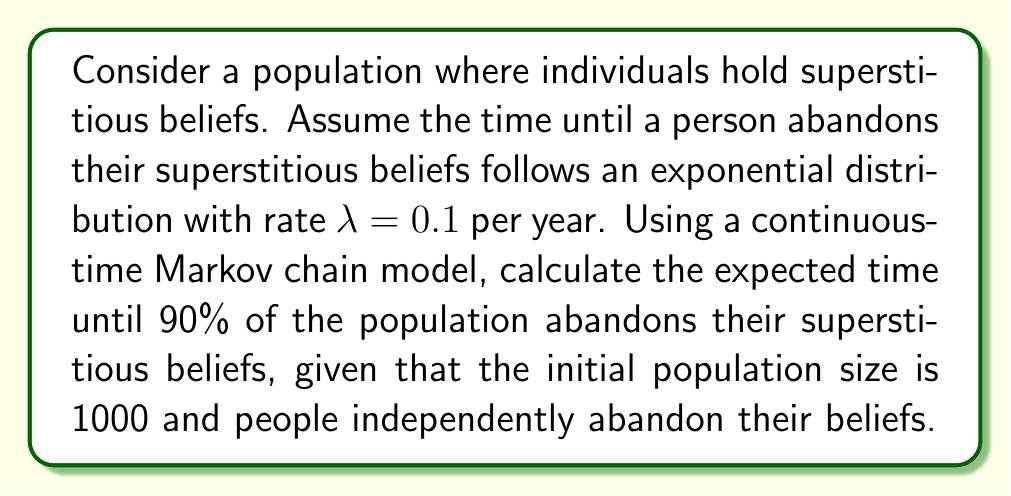Teach me how to tackle this problem. Let's approach this step-by-step:

1) First, we need to understand what we're calculating. We want the expected time until 900 people (90% of 1000) have abandoned their superstitious beliefs.

2) In a continuous-time Markov chain where each individual independently transitions at rate $\lambda$, the time until the $k$-th transition follows an Erlang distribution with parameters $k$ and $n\lambda$, where $n$ is the current number of individuals who haven't yet transitioned.

3) The probability density function of the Erlang distribution is:

   $$f(t;k,\theta) = \frac{t^{k-1}e^{-t/\theta}}{(k-1)!\theta^k}$$

   where $k$ is the shape parameter and $\theta$ is the scale parameter.

4) In our case, $k = 900$ (we want 900 people to abandon their beliefs), and $\theta = \frac{1}{n\lambda}$ where $n$ starts at 1000 and decreases with each transition.

5) The expected value of an Erlang distribution is $k\theta$. However, because $n$ is changing, we need to sum up the expected times for each transition:

   $$E[T] = \sum_{i=1}^{900} \frac{1}{(1001-i)\lambda}$$

6) This sum can be simplified to:

   $$E[T] = \frac{1}{\lambda} \sum_{i=101}^{1000} \frac{1}{i}$$

7) This is a harmonic series from 101 to 1000. We can approximate it using the natural logarithm:

   $$E[T] \approx \frac{1}{\lambda} (\ln(1000) - \ln(100))$$

8) Substituting $\lambda = 0.1$:

   $$E[T] \approx 10 (\ln(1000) - \ln(100)) = 10 \ln(10) \approx 23.03$$

Therefore, the expected time until 90% of the population abandons their superstitious beliefs is approximately 23.03 years.
Answer: 23.03 years 